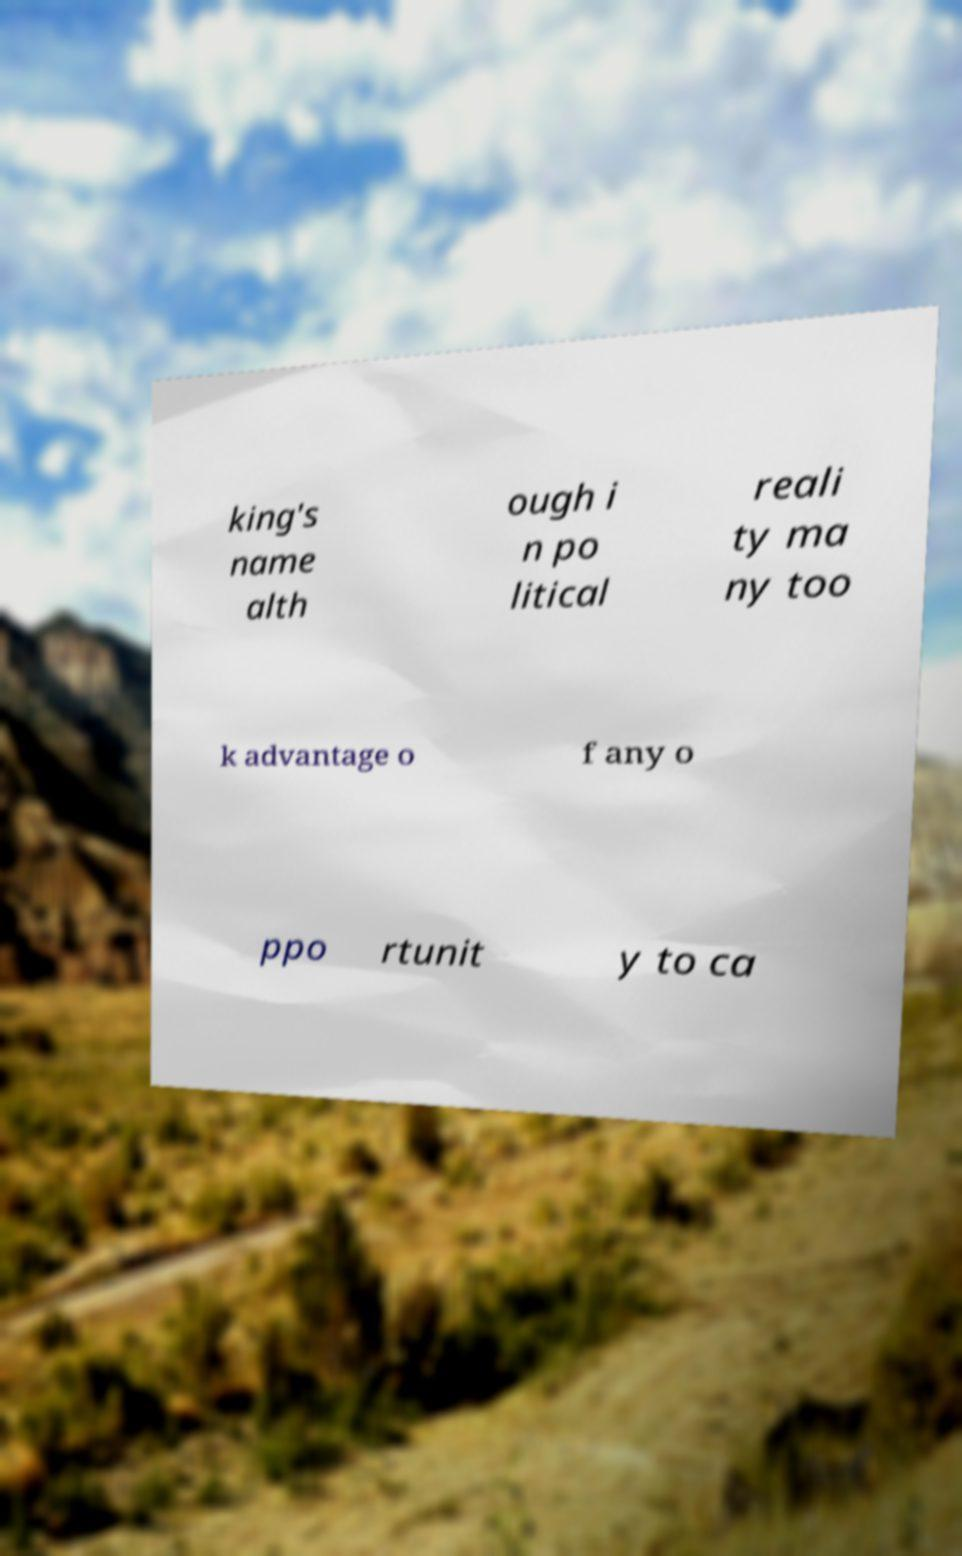For documentation purposes, I need the text within this image transcribed. Could you provide that? king's name alth ough i n po litical reali ty ma ny too k advantage o f any o ppo rtunit y to ca 